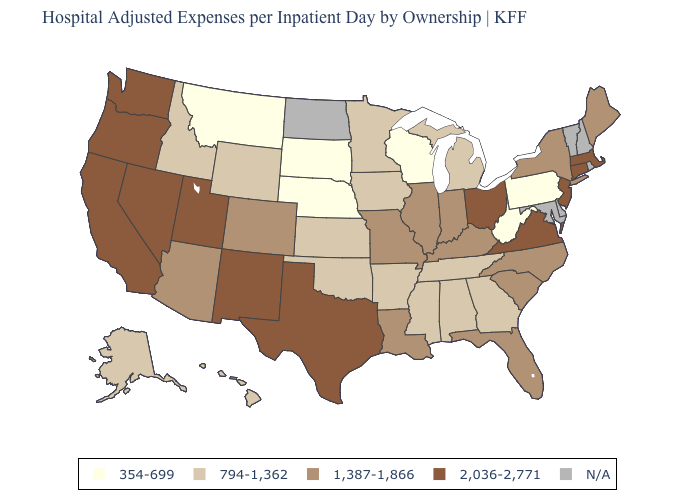Does West Virginia have the lowest value in the South?
Answer briefly. Yes. Name the states that have a value in the range 794-1,362?
Write a very short answer. Alabama, Alaska, Arkansas, Georgia, Hawaii, Idaho, Iowa, Kansas, Michigan, Minnesota, Mississippi, Oklahoma, Tennessee, Wyoming. Among the states that border Alabama , which have the highest value?
Concise answer only. Florida. What is the lowest value in the West?
Write a very short answer. 354-699. What is the value of Mississippi?
Quick response, please. 794-1,362. What is the value of Kentucky?
Quick response, please. 1,387-1,866. What is the lowest value in the USA?
Quick response, please. 354-699. What is the value of New Mexico?
Give a very brief answer. 2,036-2,771. Does California have the highest value in the West?
Answer briefly. Yes. What is the value of Maryland?
Short answer required. N/A. How many symbols are there in the legend?
Give a very brief answer. 5. Does the first symbol in the legend represent the smallest category?
Be succinct. Yes. Does the map have missing data?
Give a very brief answer. Yes. Which states hav the highest value in the MidWest?
Short answer required. Ohio. 